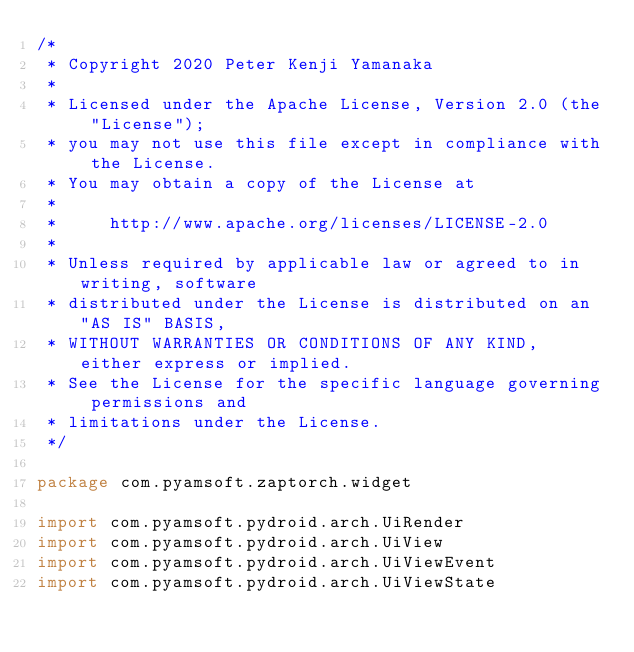<code> <loc_0><loc_0><loc_500><loc_500><_Kotlin_>/*
 * Copyright 2020 Peter Kenji Yamanaka
 *
 * Licensed under the Apache License, Version 2.0 (the "License");
 * you may not use this file except in compliance with the License.
 * You may obtain a copy of the License at
 *
 *     http://www.apache.org/licenses/LICENSE-2.0
 *
 * Unless required by applicable law or agreed to in writing, software
 * distributed under the License is distributed on an "AS IS" BASIS,
 * WITHOUT WARRANTIES OR CONDITIONS OF ANY KIND, either express or implied.
 * See the License for the specific language governing permissions and
 * limitations under the License.
 */

package com.pyamsoft.zaptorch.widget

import com.pyamsoft.pydroid.arch.UiRender
import com.pyamsoft.pydroid.arch.UiView
import com.pyamsoft.pydroid.arch.UiViewEvent
import com.pyamsoft.pydroid.arch.UiViewState</code> 